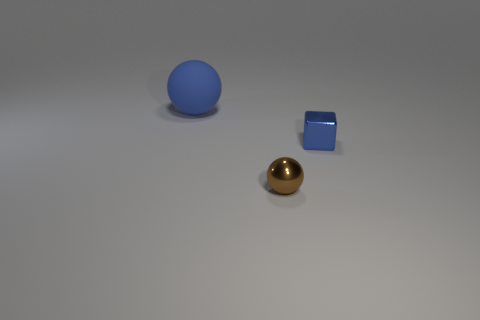The shiny thing that is the same size as the blue block is what color?
Provide a succinct answer. Brown. What number of balls are either tiny blue objects or tiny brown things?
Provide a succinct answer. 1. Is the shape of the matte thing the same as the tiny object that is behind the metal ball?
Offer a terse response. No. What number of blue metallic things have the same size as the brown shiny sphere?
Make the answer very short. 1. There is a tiny metal object that is behind the small brown metal ball; is its shape the same as the blue object left of the brown thing?
Make the answer very short. No. The tiny thing that is the same color as the large rubber thing is what shape?
Ensure brevity in your answer.  Cube. What is the color of the metal thing behind the shiny thing that is in front of the blue metallic thing?
Make the answer very short. Blue. What color is the small shiny object that is the same shape as the big blue object?
Offer a very short reply. Brown. Are there any other things that have the same material as the blue sphere?
Provide a short and direct response. No. There is another brown thing that is the same shape as the large object; what is its size?
Keep it short and to the point. Small. 